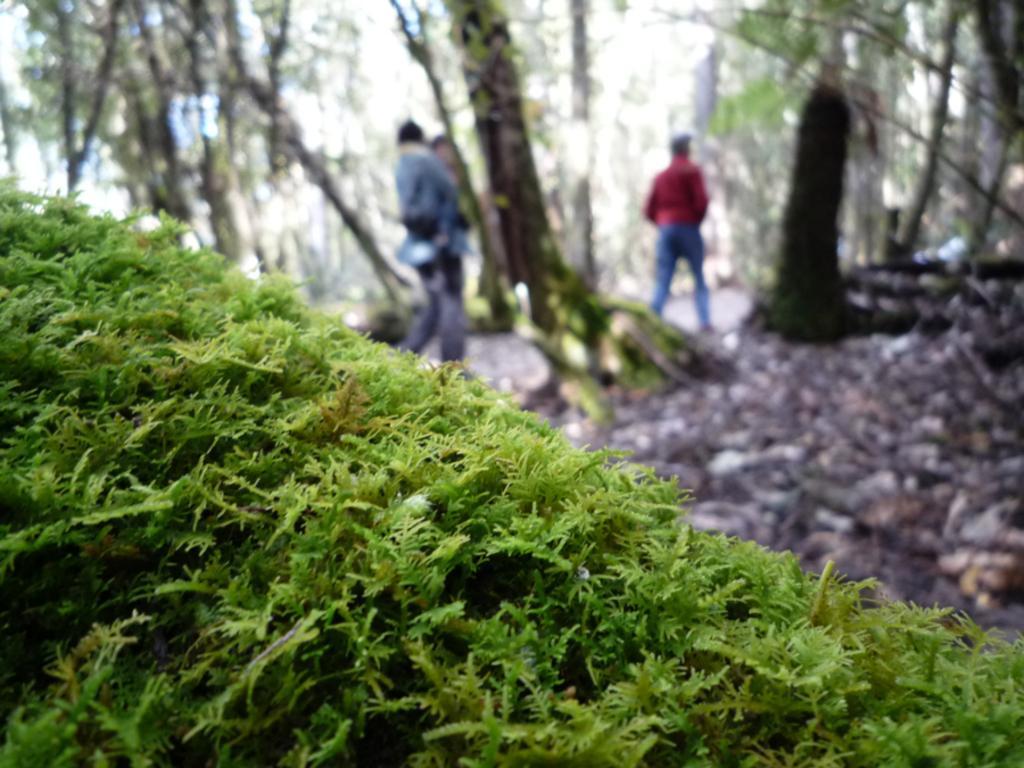Could you give a brief overview of what you see in this image? At the bottom of the image we can see moss. In the center there are people. In the background there are trees. 